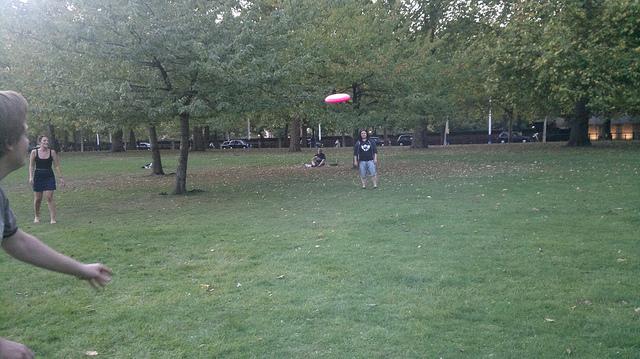What sport is being played?
Give a very brief answer. Frisbee. How many people are playing?
Quick response, please. 3. What did the dog catch?
Short answer required. Nothing. Are they standing?
Concise answer only. Yes. What color is the Frisbee?
Be succinct. Red. Is the Frisbee heading to the person on the left?
Give a very brief answer. No. Which sport are they participating?
Keep it brief. Frisbee. What is floating the photo?
Be succinct. Frisbee. What is the man throwing?
Short answer required. Frisbee. Who threw the frisbee?
Give a very brief answer. Man. What is the yellow ball on the woman's head in the back row?
Quick response, please. Tennis ball. 